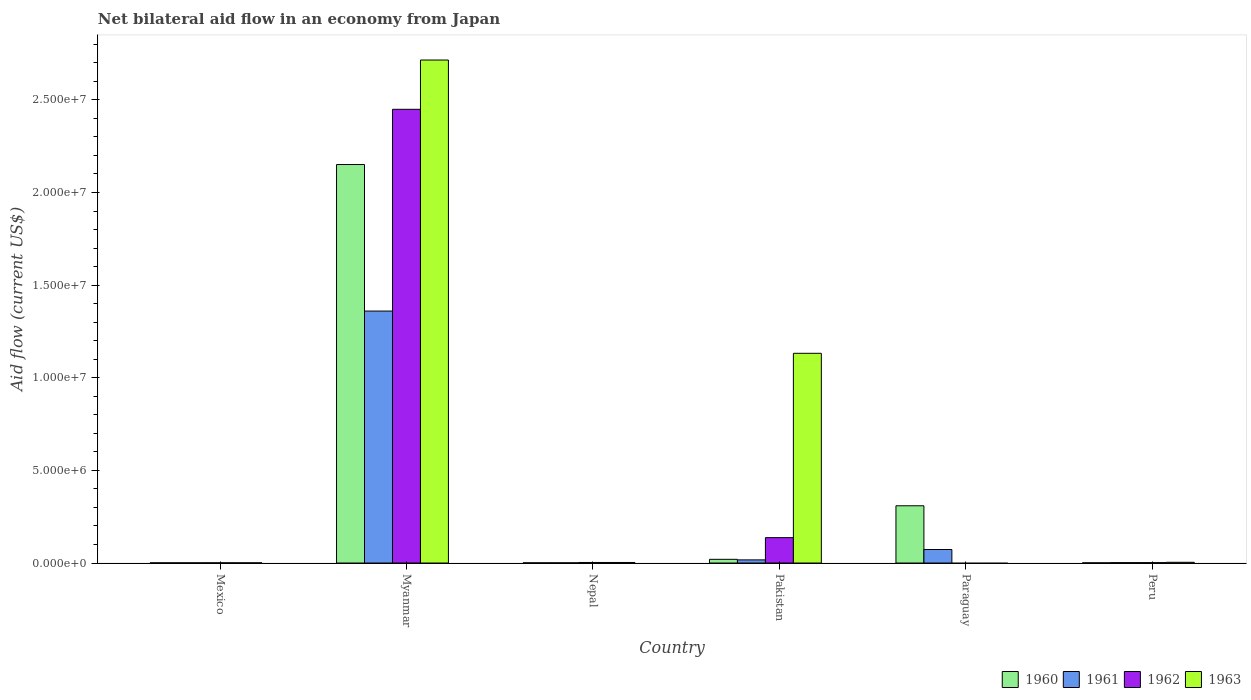How many groups of bars are there?
Offer a terse response. 6. What is the net bilateral aid flow in 1962 in Myanmar?
Your answer should be very brief. 2.45e+07. Across all countries, what is the maximum net bilateral aid flow in 1962?
Offer a terse response. 2.45e+07. In which country was the net bilateral aid flow in 1960 maximum?
Offer a very short reply. Myanmar. What is the total net bilateral aid flow in 1962 in the graph?
Provide a short and direct response. 2.59e+07. What is the difference between the net bilateral aid flow in 1961 in Peru and the net bilateral aid flow in 1960 in Paraguay?
Your response must be concise. -3.07e+06. What is the average net bilateral aid flow in 1963 per country?
Offer a very short reply. 6.42e+06. What is the difference between the net bilateral aid flow of/in 1961 and net bilateral aid flow of/in 1962 in Pakistan?
Your answer should be compact. -1.20e+06. What is the difference between the highest and the second highest net bilateral aid flow in 1961?
Provide a short and direct response. 1.34e+07. What is the difference between the highest and the lowest net bilateral aid flow in 1960?
Your answer should be compact. 2.15e+07. Is the sum of the net bilateral aid flow in 1961 in Paraguay and Peru greater than the maximum net bilateral aid flow in 1960 across all countries?
Provide a succinct answer. No. Is it the case that in every country, the sum of the net bilateral aid flow in 1960 and net bilateral aid flow in 1961 is greater than the net bilateral aid flow in 1963?
Offer a very short reply. No. How many bars are there?
Your answer should be very brief. 22. Are all the bars in the graph horizontal?
Provide a short and direct response. No. What is the difference between two consecutive major ticks on the Y-axis?
Provide a short and direct response. 5.00e+06. Are the values on the major ticks of Y-axis written in scientific E-notation?
Offer a very short reply. Yes. Does the graph contain grids?
Your response must be concise. No. How many legend labels are there?
Make the answer very short. 4. What is the title of the graph?
Offer a terse response. Net bilateral aid flow in an economy from Japan. What is the label or title of the Y-axis?
Your answer should be compact. Aid flow (current US$). What is the Aid flow (current US$) in 1960 in Mexico?
Offer a very short reply. 10000. What is the Aid flow (current US$) in 1961 in Mexico?
Your response must be concise. 10000. What is the Aid flow (current US$) of 1960 in Myanmar?
Your answer should be compact. 2.15e+07. What is the Aid flow (current US$) of 1961 in Myanmar?
Provide a succinct answer. 1.36e+07. What is the Aid flow (current US$) of 1962 in Myanmar?
Provide a succinct answer. 2.45e+07. What is the Aid flow (current US$) of 1963 in Myanmar?
Give a very brief answer. 2.72e+07. What is the Aid flow (current US$) of 1961 in Nepal?
Keep it short and to the point. 10000. What is the Aid flow (current US$) in 1960 in Pakistan?
Offer a terse response. 2.00e+05. What is the Aid flow (current US$) of 1962 in Pakistan?
Give a very brief answer. 1.37e+06. What is the Aid flow (current US$) of 1963 in Pakistan?
Keep it short and to the point. 1.13e+07. What is the Aid flow (current US$) of 1960 in Paraguay?
Offer a terse response. 3.09e+06. What is the Aid flow (current US$) of 1961 in Paraguay?
Provide a short and direct response. 7.30e+05. What is the Aid flow (current US$) in 1963 in Paraguay?
Make the answer very short. 0. What is the Aid flow (current US$) of 1961 in Peru?
Your answer should be compact. 2.00e+04. What is the Aid flow (current US$) in 1962 in Peru?
Provide a short and direct response. 2.00e+04. Across all countries, what is the maximum Aid flow (current US$) of 1960?
Offer a terse response. 2.15e+07. Across all countries, what is the maximum Aid flow (current US$) of 1961?
Offer a terse response. 1.36e+07. Across all countries, what is the maximum Aid flow (current US$) in 1962?
Keep it short and to the point. 2.45e+07. Across all countries, what is the maximum Aid flow (current US$) in 1963?
Ensure brevity in your answer.  2.72e+07. Across all countries, what is the minimum Aid flow (current US$) in 1960?
Offer a very short reply. 10000. Across all countries, what is the minimum Aid flow (current US$) in 1963?
Give a very brief answer. 0. What is the total Aid flow (current US$) in 1960 in the graph?
Ensure brevity in your answer.  2.48e+07. What is the total Aid flow (current US$) of 1961 in the graph?
Provide a succinct answer. 1.45e+07. What is the total Aid flow (current US$) of 1962 in the graph?
Give a very brief answer. 2.59e+07. What is the total Aid flow (current US$) in 1963 in the graph?
Offer a terse response. 3.86e+07. What is the difference between the Aid flow (current US$) of 1960 in Mexico and that in Myanmar?
Make the answer very short. -2.15e+07. What is the difference between the Aid flow (current US$) of 1961 in Mexico and that in Myanmar?
Ensure brevity in your answer.  -1.36e+07. What is the difference between the Aid flow (current US$) in 1962 in Mexico and that in Myanmar?
Offer a terse response. -2.45e+07. What is the difference between the Aid flow (current US$) in 1963 in Mexico and that in Myanmar?
Offer a terse response. -2.71e+07. What is the difference between the Aid flow (current US$) in 1962 in Mexico and that in Nepal?
Your answer should be very brief. -2.00e+04. What is the difference between the Aid flow (current US$) of 1963 in Mexico and that in Nepal?
Ensure brevity in your answer.  -2.00e+04. What is the difference between the Aid flow (current US$) of 1960 in Mexico and that in Pakistan?
Offer a very short reply. -1.90e+05. What is the difference between the Aid flow (current US$) in 1961 in Mexico and that in Pakistan?
Ensure brevity in your answer.  -1.60e+05. What is the difference between the Aid flow (current US$) in 1962 in Mexico and that in Pakistan?
Provide a succinct answer. -1.36e+06. What is the difference between the Aid flow (current US$) in 1963 in Mexico and that in Pakistan?
Provide a short and direct response. -1.13e+07. What is the difference between the Aid flow (current US$) of 1960 in Mexico and that in Paraguay?
Keep it short and to the point. -3.08e+06. What is the difference between the Aid flow (current US$) in 1961 in Mexico and that in Paraguay?
Offer a very short reply. -7.20e+05. What is the difference between the Aid flow (current US$) in 1961 in Mexico and that in Peru?
Ensure brevity in your answer.  -10000. What is the difference between the Aid flow (current US$) in 1962 in Mexico and that in Peru?
Keep it short and to the point. -10000. What is the difference between the Aid flow (current US$) of 1960 in Myanmar and that in Nepal?
Make the answer very short. 2.15e+07. What is the difference between the Aid flow (current US$) of 1961 in Myanmar and that in Nepal?
Your answer should be very brief. 1.36e+07. What is the difference between the Aid flow (current US$) in 1962 in Myanmar and that in Nepal?
Provide a succinct answer. 2.45e+07. What is the difference between the Aid flow (current US$) in 1963 in Myanmar and that in Nepal?
Offer a very short reply. 2.71e+07. What is the difference between the Aid flow (current US$) in 1960 in Myanmar and that in Pakistan?
Provide a succinct answer. 2.13e+07. What is the difference between the Aid flow (current US$) in 1961 in Myanmar and that in Pakistan?
Ensure brevity in your answer.  1.34e+07. What is the difference between the Aid flow (current US$) in 1962 in Myanmar and that in Pakistan?
Ensure brevity in your answer.  2.31e+07. What is the difference between the Aid flow (current US$) in 1963 in Myanmar and that in Pakistan?
Provide a short and direct response. 1.58e+07. What is the difference between the Aid flow (current US$) of 1960 in Myanmar and that in Paraguay?
Offer a terse response. 1.84e+07. What is the difference between the Aid flow (current US$) of 1961 in Myanmar and that in Paraguay?
Provide a short and direct response. 1.29e+07. What is the difference between the Aid flow (current US$) in 1960 in Myanmar and that in Peru?
Ensure brevity in your answer.  2.15e+07. What is the difference between the Aid flow (current US$) in 1961 in Myanmar and that in Peru?
Provide a short and direct response. 1.36e+07. What is the difference between the Aid flow (current US$) of 1962 in Myanmar and that in Peru?
Ensure brevity in your answer.  2.45e+07. What is the difference between the Aid flow (current US$) of 1963 in Myanmar and that in Peru?
Your response must be concise. 2.71e+07. What is the difference between the Aid flow (current US$) of 1960 in Nepal and that in Pakistan?
Give a very brief answer. -1.90e+05. What is the difference between the Aid flow (current US$) of 1961 in Nepal and that in Pakistan?
Provide a succinct answer. -1.60e+05. What is the difference between the Aid flow (current US$) in 1962 in Nepal and that in Pakistan?
Keep it short and to the point. -1.34e+06. What is the difference between the Aid flow (current US$) in 1963 in Nepal and that in Pakistan?
Provide a short and direct response. -1.13e+07. What is the difference between the Aid flow (current US$) in 1960 in Nepal and that in Paraguay?
Give a very brief answer. -3.08e+06. What is the difference between the Aid flow (current US$) of 1961 in Nepal and that in Paraguay?
Keep it short and to the point. -7.20e+05. What is the difference between the Aid flow (current US$) in 1960 in Nepal and that in Peru?
Provide a succinct answer. 0. What is the difference between the Aid flow (current US$) of 1963 in Nepal and that in Peru?
Make the answer very short. -10000. What is the difference between the Aid flow (current US$) of 1960 in Pakistan and that in Paraguay?
Your response must be concise. -2.89e+06. What is the difference between the Aid flow (current US$) in 1961 in Pakistan and that in Paraguay?
Ensure brevity in your answer.  -5.60e+05. What is the difference between the Aid flow (current US$) in 1962 in Pakistan and that in Peru?
Provide a short and direct response. 1.35e+06. What is the difference between the Aid flow (current US$) in 1963 in Pakistan and that in Peru?
Make the answer very short. 1.13e+07. What is the difference between the Aid flow (current US$) in 1960 in Paraguay and that in Peru?
Ensure brevity in your answer.  3.08e+06. What is the difference between the Aid flow (current US$) of 1961 in Paraguay and that in Peru?
Provide a short and direct response. 7.10e+05. What is the difference between the Aid flow (current US$) of 1960 in Mexico and the Aid flow (current US$) of 1961 in Myanmar?
Offer a very short reply. -1.36e+07. What is the difference between the Aid flow (current US$) of 1960 in Mexico and the Aid flow (current US$) of 1962 in Myanmar?
Keep it short and to the point. -2.45e+07. What is the difference between the Aid flow (current US$) of 1960 in Mexico and the Aid flow (current US$) of 1963 in Myanmar?
Provide a short and direct response. -2.71e+07. What is the difference between the Aid flow (current US$) in 1961 in Mexico and the Aid flow (current US$) in 1962 in Myanmar?
Give a very brief answer. -2.45e+07. What is the difference between the Aid flow (current US$) of 1961 in Mexico and the Aid flow (current US$) of 1963 in Myanmar?
Offer a terse response. -2.71e+07. What is the difference between the Aid flow (current US$) of 1962 in Mexico and the Aid flow (current US$) of 1963 in Myanmar?
Make the answer very short. -2.71e+07. What is the difference between the Aid flow (current US$) of 1960 in Mexico and the Aid flow (current US$) of 1961 in Nepal?
Provide a short and direct response. 0. What is the difference between the Aid flow (current US$) in 1960 in Mexico and the Aid flow (current US$) in 1963 in Nepal?
Give a very brief answer. -2.00e+04. What is the difference between the Aid flow (current US$) in 1961 in Mexico and the Aid flow (current US$) in 1962 in Nepal?
Ensure brevity in your answer.  -2.00e+04. What is the difference between the Aid flow (current US$) in 1961 in Mexico and the Aid flow (current US$) in 1963 in Nepal?
Make the answer very short. -2.00e+04. What is the difference between the Aid flow (current US$) in 1962 in Mexico and the Aid flow (current US$) in 1963 in Nepal?
Your response must be concise. -2.00e+04. What is the difference between the Aid flow (current US$) in 1960 in Mexico and the Aid flow (current US$) in 1962 in Pakistan?
Provide a succinct answer. -1.36e+06. What is the difference between the Aid flow (current US$) of 1960 in Mexico and the Aid flow (current US$) of 1963 in Pakistan?
Provide a short and direct response. -1.13e+07. What is the difference between the Aid flow (current US$) in 1961 in Mexico and the Aid flow (current US$) in 1962 in Pakistan?
Give a very brief answer. -1.36e+06. What is the difference between the Aid flow (current US$) in 1961 in Mexico and the Aid flow (current US$) in 1963 in Pakistan?
Offer a very short reply. -1.13e+07. What is the difference between the Aid flow (current US$) of 1962 in Mexico and the Aid flow (current US$) of 1963 in Pakistan?
Your answer should be compact. -1.13e+07. What is the difference between the Aid flow (current US$) of 1960 in Mexico and the Aid flow (current US$) of 1961 in Paraguay?
Ensure brevity in your answer.  -7.20e+05. What is the difference between the Aid flow (current US$) of 1960 in Mexico and the Aid flow (current US$) of 1961 in Peru?
Offer a terse response. -10000. What is the difference between the Aid flow (current US$) in 1960 in Mexico and the Aid flow (current US$) in 1963 in Peru?
Your answer should be very brief. -3.00e+04. What is the difference between the Aid flow (current US$) in 1962 in Mexico and the Aid flow (current US$) in 1963 in Peru?
Make the answer very short. -3.00e+04. What is the difference between the Aid flow (current US$) of 1960 in Myanmar and the Aid flow (current US$) of 1961 in Nepal?
Give a very brief answer. 2.15e+07. What is the difference between the Aid flow (current US$) in 1960 in Myanmar and the Aid flow (current US$) in 1962 in Nepal?
Make the answer very short. 2.15e+07. What is the difference between the Aid flow (current US$) in 1960 in Myanmar and the Aid flow (current US$) in 1963 in Nepal?
Your answer should be very brief. 2.15e+07. What is the difference between the Aid flow (current US$) in 1961 in Myanmar and the Aid flow (current US$) in 1962 in Nepal?
Your response must be concise. 1.36e+07. What is the difference between the Aid flow (current US$) of 1961 in Myanmar and the Aid flow (current US$) of 1963 in Nepal?
Keep it short and to the point. 1.36e+07. What is the difference between the Aid flow (current US$) in 1962 in Myanmar and the Aid flow (current US$) in 1963 in Nepal?
Give a very brief answer. 2.45e+07. What is the difference between the Aid flow (current US$) of 1960 in Myanmar and the Aid flow (current US$) of 1961 in Pakistan?
Offer a terse response. 2.13e+07. What is the difference between the Aid flow (current US$) of 1960 in Myanmar and the Aid flow (current US$) of 1962 in Pakistan?
Offer a very short reply. 2.01e+07. What is the difference between the Aid flow (current US$) in 1960 in Myanmar and the Aid flow (current US$) in 1963 in Pakistan?
Offer a terse response. 1.02e+07. What is the difference between the Aid flow (current US$) in 1961 in Myanmar and the Aid flow (current US$) in 1962 in Pakistan?
Provide a succinct answer. 1.22e+07. What is the difference between the Aid flow (current US$) of 1961 in Myanmar and the Aid flow (current US$) of 1963 in Pakistan?
Your answer should be very brief. 2.28e+06. What is the difference between the Aid flow (current US$) in 1962 in Myanmar and the Aid flow (current US$) in 1963 in Pakistan?
Make the answer very short. 1.32e+07. What is the difference between the Aid flow (current US$) in 1960 in Myanmar and the Aid flow (current US$) in 1961 in Paraguay?
Your response must be concise. 2.08e+07. What is the difference between the Aid flow (current US$) in 1960 in Myanmar and the Aid flow (current US$) in 1961 in Peru?
Give a very brief answer. 2.15e+07. What is the difference between the Aid flow (current US$) in 1960 in Myanmar and the Aid flow (current US$) in 1962 in Peru?
Make the answer very short. 2.15e+07. What is the difference between the Aid flow (current US$) of 1960 in Myanmar and the Aid flow (current US$) of 1963 in Peru?
Your answer should be very brief. 2.15e+07. What is the difference between the Aid flow (current US$) in 1961 in Myanmar and the Aid flow (current US$) in 1962 in Peru?
Provide a succinct answer. 1.36e+07. What is the difference between the Aid flow (current US$) in 1961 in Myanmar and the Aid flow (current US$) in 1963 in Peru?
Keep it short and to the point. 1.36e+07. What is the difference between the Aid flow (current US$) in 1962 in Myanmar and the Aid flow (current US$) in 1963 in Peru?
Your answer should be compact. 2.44e+07. What is the difference between the Aid flow (current US$) in 1960 in Nepal and the Aid flow (current US$) in 1962 in Pakistan?
Make the answer very short. -1.36e+06. What is the difference between the Aid flow (current US$) in 1960 in Nepal and the Aid flow (current US$) in 1963 in Pakistan?
Provide a succinct answer. -1.13e+07. What is the difference between the Aid flow (current US$) in 1961 in Nepal and the Aid flow (current US$) in 1962 in Pakistan?
Your response must be concise. -1.36e+06. What is the difference between the Aid flow (current US$) of 1961 in Nepal and the Aid flow (current US$) of 1963 in Pakistan?
Your response must be concise. -1.13e+07. What is the difference between the Aid flow (current US$) of 1962 in Nepal and the Aid flow (current US$) of 1963 in Pakistan?
Give a very brief answer. -1.13e+07. What is the difference between the Aid flow (current US$) in 1960 in Nepal and the Aid flow (current US$) in 1961 in Paraguay?
Your answer should be compact. -7.20e+05. What is the difference between the Aid flow (current US$) of 1962 in Nepal and the Aid flow (current US$) of 1963 in Peru?
Offer a very short reply. -10000. What is the difference between the Aid flow (current US$) in 1960 in Pakistan and the Aid flow (current US$) in 1961 in Paraguay?
Offer a very short reply. -5.30e+05. What is the difference between the Aid flow (current US$) in 1960 in Pakistan and the Aid flow (current US$) in 1961 in Peru?
Your response must be concise. 1.80e+05. What is the difference between the Aid flow (current US$) of 1960 in Pakistan and the Aid flow (current US$) of 1962 in Peru?
Ensure brevity in your answer.  1.80e+05. What is the difference between the Aid flow (current US$) in 1960 in Pakistan and the Aid flow (current US$) in 1963 in Peru?
Your answer should be very brief. 1.60e+05. What is the difference between the Aid flow (current US$) of 1962 in Pakistan and the Aid flow (current US$) of 1963 in Peru?
Offer a terse response. 1.33e+06. What is the difference between the Aid flow (current US$) in 1960 in Paraguay and the Aid flow (current US$) in 1961 in Peru?
Your answer should be compact. 3.07e+06. What is the difference between the Aid flow (current US$) in 1960 in Paraguay and the Aid flow (current US$) in 1962 in Peru?
Your response must be concise. 3.07e+06. What is the difference between the Aid flow (current US$) of 1960 in Paraguay and the Aid flow (current US$) of 1963 in Peru?
Your answer should be very brief. 3.05e+06. What is the difference between the Aid flow (current US$) of 1961 in Paraguay and the Aid flow (current US$) of 1962 in Peru?
Keep it short and to the point. 7.10e+05. What is the difference between the Aid flow (current US$) in 1961 in Paraguay and the Aid flow (current US$) in 1963 in Peru?
Ensure brevity in your answer.  6.90e+05. What is the average Aid flow (current US$) of 1960 per country?
Offer a very short reply. 4.14e+06. What is the average Aid flow (current US$) in 1961 per country?
Offer a terse response. 2.42e+06. What is the average Aid flow (current US$) in 1962 per country?
Give a very brief answer. 4.32e+06. What is the average Aid flow (current US$) of 1963 per country?
Keep it short and to the point. 6.42e+06. What is the difference between the Aid flow (current US$) of 1960 and Aid flow (current US$) of 1962 in Mexico?
Ensure brevity in your answer.  0. What is the difference between the Aid flow (current US$) of 1961 and Aid flow (current US$) of 1962 in Mexico?
Provide a succinct answer. 0. What is the difference between the Aid flow (current US$) in 1962 and Aid flow (current US$) in 1963 in Mexico?
Your answer should be compact. 0. What is the difference between the Aid flow (current US$) of 1960 and Aid flow (current US$) of 1961 in Myanmar?
Give a very brief answer. 7.91e+06. What is the difference between the Aid flow (current US$) of 1960 and Aid flow (current US$) of 1962 in Myanmar?
Provide a short and direct response. -2.98e+06. What is the difference between the Aid flow (current US$) of 1960 and Aid flow (current US$) of 1963 in Myanmar?
Offer a very short reply. -5.64e+06. What is the difference between the Aid flow (current US$) of 1961 and Aid flow (current US$) of 1962 in Myanmar?
Keep it short and to the point. -1.09e+07. What is the difference between the Aid flow (current US$) in 1961 and Aid flow (current US$) in 1963 in Myanmar?
Make the answer very short. -1.36e+07. What is the difference between the Aid flow (current US$) in 1962 and Aid flow (current US$) in 1963 in Myanmar?
Keep it short and to the point. -2.66e+06. What is the difference between the Aid flow (current US$) of 1960 and Aid flow (current US$) of 1961 in Nepal?
Offer a very short reply. 0. What is the difference between the Aid flow (current US$) of 1960 and Aid flow (current US$) of 1963 in Nepal?
Provide a succinct answer. -2.00e+04. What is the difference between the Aid flow (current US$) of 1961 and Aid flow (current US$) of 1963 in Nepal?
Offer a very short reply. -2.00e+04. What is the difference between the Aid flow (current US$) of 1960 and Aid flow (current US$) of 1962 in Pakistan?
Provide a short and direct response. -1.17e+06. What is the difference between the Aid flow (current US$) of 1960 and Aid flow (current US$) of 1963 in Pakistan?
Offer a terse response. -1.11e+07. What is the difference between the Aid flow (current US$) of 1961 and Aid flow (current US$) of 1962 in Pakistan?
Your response must be concise. -1.20e+06. What is the difference between the Aid flow (current US$) of 1961 and Aid flow (current US$) of 1963 in Pakistan?
Provide a short and direct response. -1.12e+07. What is the difference between the Aid flow (current US$) of 1962 and Aid flow (current US$) of 1963 in Pakistan?
Ensure brevity in your answer.  -9.95e+06. What is the difference between the Aid flow (current US$) of 1960 and Aid flow (current US$) of 1961 in Paraguay?
Ensure brevity in your answer.  2.36e+06. What is the difference between the Aid flow (current US$) in 1960 and Aid flow (current US$) in 1962 in Peru?
Your answer should be compact. -10000. What is the difference between the Aid flow (current US$) of 1961 and Aid flow (current US$) of 1962 in Peru?
Ensure brevity in your answer.  0. What is the difference between the Aid flow (current US$) of 1961 and Aid flow (current US$) of 1963 in Peru?
Provide a short and direct response. -2.00e+04. What is the ratio of the Aid flow (current US$) in 1960 in Mexico to that in Myanmar?
Give a very brief answer. 0. What is the ratio of the Aid flow (current US$) of 1961 in Mexico to that in Myanmar?
Ensure brevity in your answer.  0. What is the ratio of the Aid flow (current US$) of 1962 in Mexico to that in Myanmar?
Give a very brief answer. 0. What is the ratio of the Aid flow (current US$) in 1963 in Mexico to that in Myanmar?
Your answer should be very brief. 0. What is the ratio of the Aid flow (current US$) in 1960 in Mexico to that in Nepal?
Ensure brevity in your answer.  1. What is the ratio of the Aid flow (current US$) of 1962 in Mexico to that in Nepal?
Offer a very short reply. 0.33. What is the ratio of the Aid flow (current US$) in 1961 in Mexico to that in Pakistan?
Your answer should be compact. 0.06. What is the ratio of the Aid flow (current US$) in 1962 in Mexico to that in Pakistan?
Provide a succinct answer. 0.01. What is the ratio of the Aid flow (current US$) in 1963 in Mexico to that in Pakistan?
Ensure brevity in your answer.  0. What is the ratio of the Aid flow (current US$) of 1960 in Mexico to that in Paraguay?
Your answer should be very brief. 0. What is the ratio of the Aid flow (current US$) in 1961 in Mexico to that in Paraguay?
Provide a succinct answer. 0.01. What is the ratio of the Aid flow (current US$) in 1960 in Mexico to that in Peru?
Your answer should be compact. 1. What is the ratio of the Aid flow (current US$) of 1961 in Mexico to that in Peru?
Provide a short and direct response. 0.5. What is the ratio of the Aid flow (current US$) in 1962 in Mexico to that in Peru?
Keep it short and to the point. 0.5. What is the ratio of the Aid flow (current US$) in 1963 in Mexico to that in Peru?
Provide a short and direct response. 0.25. What is the ratio of the Aid flow (current US$) of 1960 in Myanmar to that in Nepal?
Offer a terse response. 2151. What is the ratio of the Aid flow (current US$) of 1961 in Myanmar to that in Nepal?
Your answer should be compact. 1360. What is the ratio of the Aid flow (current US$) in 1962 in Myanmar to that in Nepal?
Offer a terse response. 816.33. What is the ratio of the Aid flow (current US$) in 1963 in Myanmar to that in Nepal?
Offer a terse response. 905. What is the ratio of the Aid flow (current US$) in 1960 in Myanmar to that in Pakistan?
Your answer should be compact. 107.55. What is the ratio of the Aid flow (current US$) of 1962 in Myanmar to that in Pakistan?
Your answer should be very brief. 17.88. What is the ratio of the Aid flow (current US$) in 1963 in Myanmar to that in Pakistan?
Make the answer very short. 2.4. What is the ratio of the Aid flow (current US$) in 1960 in Myanmar to that in Paraguay?
Your answer should be very brief. 6.96. What is the ratio of the Aid flow (current US$) of 1961 in Myanmar to that in Paraguay?
Provide a short and direct response. 18.63. What is the ratio of the Aid flow (current US$) in 1960 in Myanmar to that in Peru?
Your answer should be very brief. 2151. What is the ratio of the Aid flow (current US$) of 1961 in Myanmar to that in Peru?
Your answer should be very brief. 680. What is the ratio of the Aid flow (current US$) of 1962 in Myanmar to that in Peru?
Keep it short and to the point. 1224.5. What is the ratio of the Aid flow (current US$) of 1963 in Myanmar to that in Peru?
Your answer should be compact. 678.75. What is the ratio of the Aid flow (current US$) in 1961 in Nepal to that in Pakistan?
Make the answer very short. 0.06. What is the ratio of the Aid flow (current US$) of 1962 in Nepal to that in Pakistan?
Your answer should be compact. 0.02. What is the ratio of the Aid flow (current US$) of 1963 in Nepal to that in Pakistan?
Give a very brief answer. 0. What is the ratio of the Aid flow (current US$) in 1960 in Nepal to that in Paraguay?
Ensure brevity in your answer.  0. What is the ratio of the Aid flow (current US$) of 1961 in Nepal to that in Paraguay?
Keep it short and to the point. 0.01. What is the ratio of the Aid flow (current US$) in 1960 in Pakistan to that in Paraguay?
Offer a terse response. 0.06. What is the ratio of the Aid flow (current US$) of 1961 in Pakistan to that in Paraguay?
Offer a terse response. 0.23. What is the ratio of the Aid flow (current US$) in 1960 in Pakistan to that in Peru?
Make the answer very short. 20. What is the ratio of the Aid flow (current US$) in 1961 in Pakistan to that in Peru?
Make the answer very short. 8.5. What is the ratio of the Aid flow (current US$) of 1962 in Pakistan to that in Peru?
Provide a succinct answer. 68.5. What is the ratio of the Aid flow (current US$) in 1963 in Pakistan to that in Peru?
Make the answer very short. 283. What is the ratio of the Aid flow (current US$) in 1960 in Paraguay to that in Peru?
Offer a terse response. 309. What is the ratio of the Aid flow (current US$) in 1961 in Paraguay to that in Peru?
Your answer should be very brief. 36.5. What is the difference between the highest and the second highest Aid flow (current US$) of 1960?
Offer a very short reply. 1.84e+07. What is the difference between the highest and the second highest Aid flow (current US$) in 1961?
Your answer should be very brief. 1.29e+07. What is the difference between the highest and the second highest Aid flow (current US$) in 1962?
Offer a terse response. 2.31e+07. What is the difference between the highest and the second highest Aid flow (current US$) of 1963?
Provide a short and direct response. 1.58e+07. What is the difference between the highest and the lowest Aid flow (current US$) in 1960?
Offer a very short reply. 2.15e+07. What is the difference between the highest and the lowest Aid flow (current US$) of 1961?
Your answer should be very brief. 1.36e+07. What is the difference between the highest and the lowest Aid flow (current US$) in 1962?
Ensure brevity in your answer.  2.45e+07. What is the difference between the highest and the lowest Aid flow (current US$) of 1963?
Provide a succinct answer. 2.72e+07. 